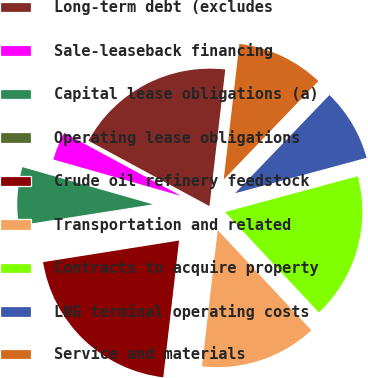Convert chart. <chart><loc_0><loc_0><loc_500><loc_500><pie_chart><fcel>Long-term debt (excludes<fcel>Sale-leaseback financing<fcel>Capital lease obligations (a)<fcel>Operating lease obligations<fcel>Crude oil refinery feedstock<fcel>Transportation and related<fcel>Contracts to acquire property<fcel>LNG terminal operating costs<fcel>Service and materials<nl><fcel>18.95%<fcel>3.46%<fcel>6.91%<fcel>0.02%<fcel>20.67%<fcel>13.79%<fcel>17.23%<fcel>8.63%<fcel>10.35%<nl></chart> 